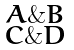<formula> <loc_0><loc_0><loc_500><loc_500>\begin{smallmatrix} A \& B \\ C \& D \end{smallmatrix}</formula> 